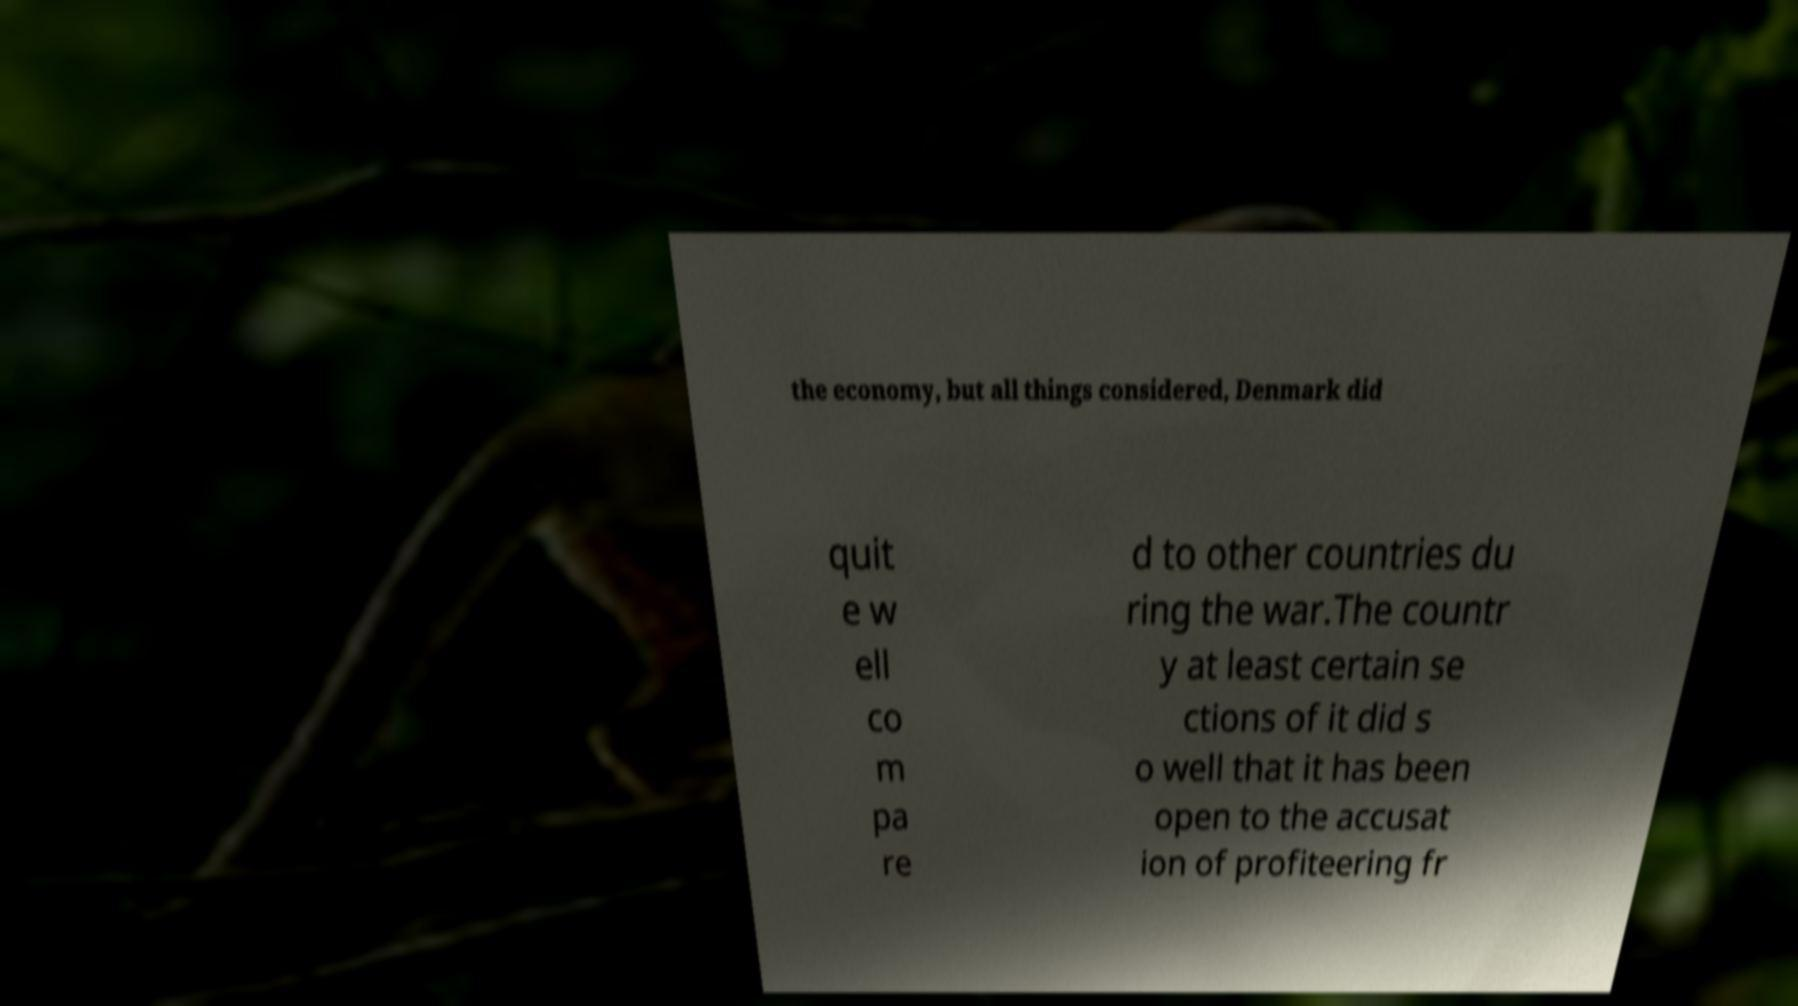For documentation purposes, I need the text within this image transcribed. Could you provide that? the economy, but all things considered, Denmark did quit e w ell co m pa re d to other countries du ring the war.The countr y at least certain se ctions of it did s o well that it has been open to the accusat ion of profiteering fr 